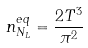<formula> <loc_0><loc_0><loc_500><loc_500>n _ { N _ { L } } ^ { e q } = \frac { 2 T ^ { 3 } } { \pi ^ { 2 } }</formula> 